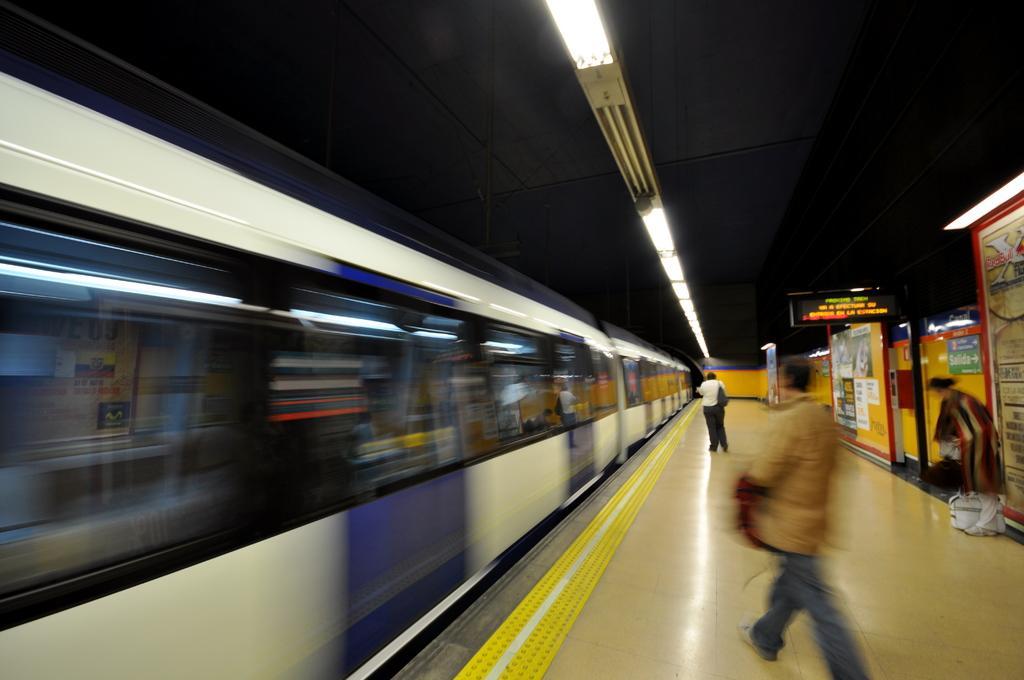In one or two sentences, can you explain what this image depicts? To the left side of the image there is a train. At the top of the image there is a ceiling with lights. There are people walking to the right side of the image. 